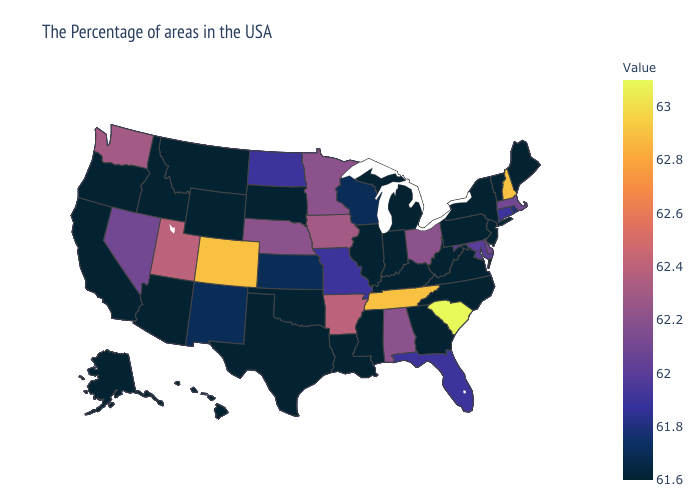Which states hav the highest value in the Northeast?
Concise answer only. New Hampshire. Which states have the lowest value in the MidWest?
Short answer required. Michigan, Indiana, Illinois, South Dakota. Which states have the highest value in the USA?
Answer briefly. South Carolina. 